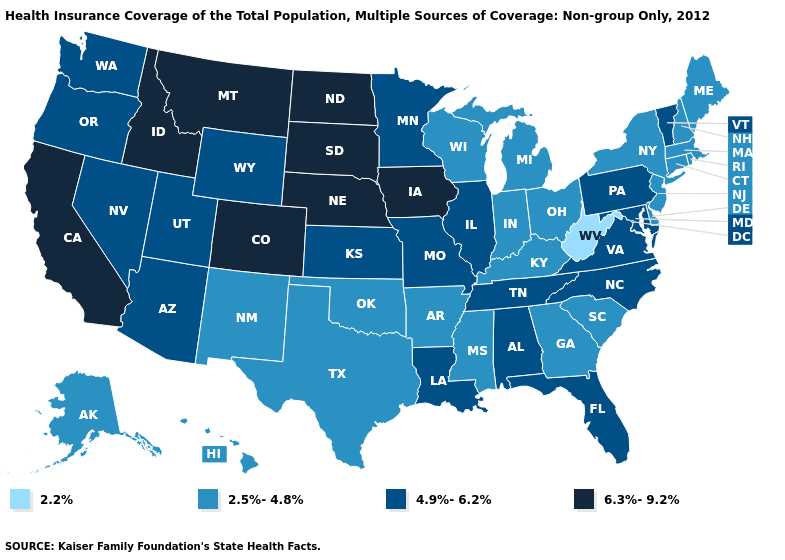What is the lowest value in the West?
Be succinct. 2.5%-4.8%. Does Virginia have a higher value than Alaska?
Be succinct. Yes. How many symbols are there in the legend?
Answer briefly. 4. Which states have the highest value in the USA?
Concise answer only. California, Colorado, Idaho, Iowa, Montana, Nebraska, North Dakota, South Dakota. What is the value of Tennessee?
Quick response, please. 4.9%-6.2%. Among the states that border Ohio , does West Virginia have the highest value?
Keep it brief. No. What is the value of Maryland?
Keep it brief. 4.9%-6.2%. What is the value of Colorado?
Short answer required. 6.3%-9.2%. What is the highest value in the USA?
Be succinct. 6.3%-9.2%. Name the states that have a value in the range 2.2%?
Write a very short answer. West Virginia. What is the lowest value in the USA?
Keep it brief. 2.2%. Which states have the lowest value in the Northeast?
Short answer required. Connecticut, Maine, Massachusetts, New Hampshire, New Jersey, New York, Rhode Island. Does South Carolina have the highest value in the South?
Keep it brief. No. Does the first symbol in the legend represent the smallest category?
Concise answer only. Yes. What is the highest value in states that border Georgia?
Write a very short answer. 4.9%-6.2%. 